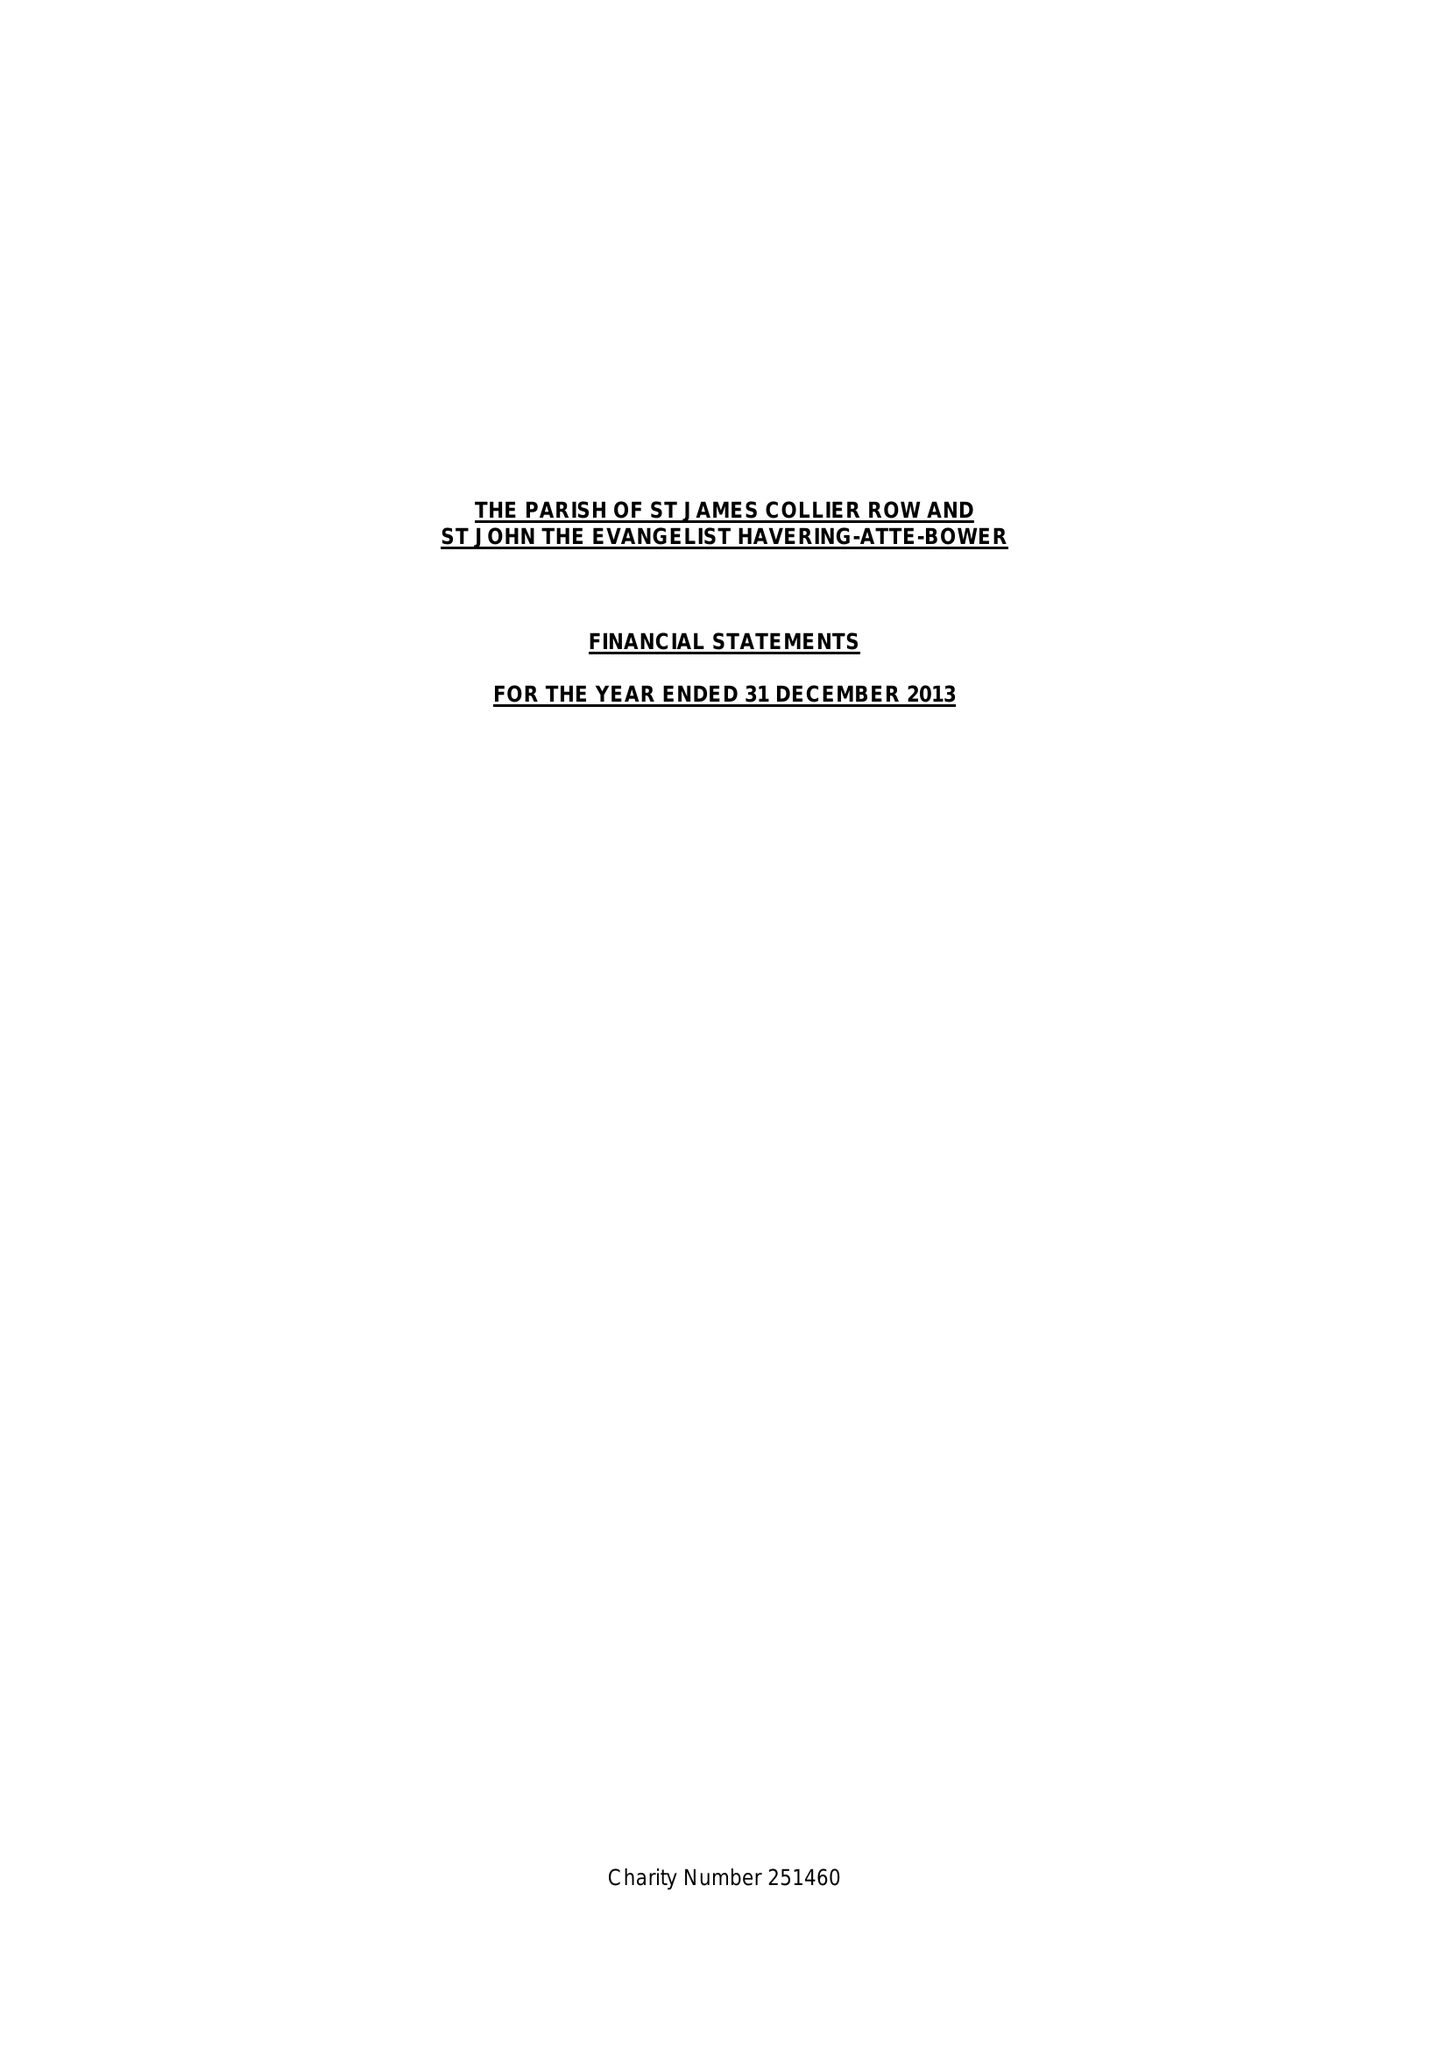What is the value for the address__post_town?
Answer the question using a single word or phrase. ROMFORD 